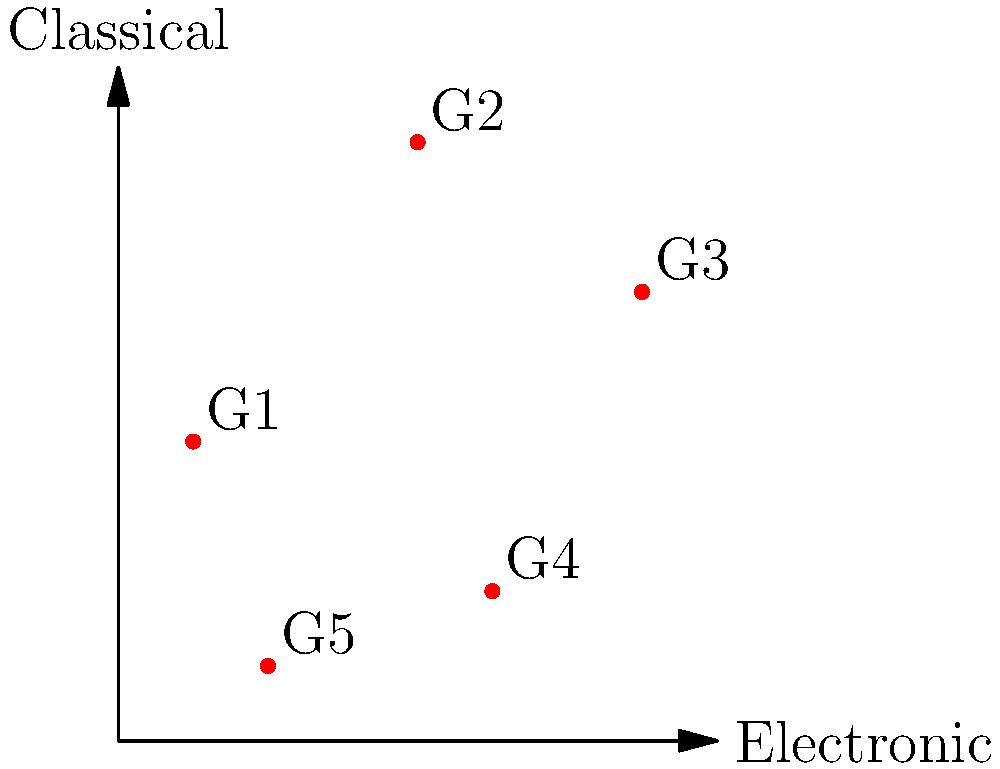In a study on the evolution of electronic music, five genres (G1 to G5) are plotted on a scatter plot based on their electronic and classical influences. The coordinates of these genres are G1(0,0), G2(3,4), G3(6,2), G4(4,-2), and G5(1,-3). Calculate the area of the polygon formed by connecting these points in the order given. How does this area relate to the diversity of electronic music genres? To calculate the area of the polygon, we can use the Shoelace formula (also known as the surveyor's formula). The steps are as follows:

1) The Shoelace formula for a polygon with vertices $(x_1, y_1), (x_2, y_2), ..., (x_n, y_n)$ is:

   $$Area = \frac{1}{2}|(x_1y_2 + x_2y_3 + ... + x_ny_1) - (y_1x_2 + y_2x_3 + ... + y_nx_1)|$$

2) Substituting our points:
   $$(x_1, y_1) = (0, 0)$$
   $$(x_2, y_2) = (3, 4)$$
   $$(x_3, y_3) = (6, 2)$$
   $$(x_4, y_4) = (4, -2)$$
   $$(x_5, y_5) = (1, -3)$$

3) Applying the formula:

   $$Area = \frac{1}{2}|(0\cdot4 + 3\cdot2 + 6\cdot(-2) + 4\cdot(-3) + 1\cdot0) - (0\cdot3 + 4\cdot6 + 2\cdot4 + (-2)\cdot1 + (-3)\cdot0)|$$

4) Simplifying:

   $$Area = \frac{1}{2}|(0 + 6 - 12 - 12 + 0) - (0 + 24 + 8 - 2 + 0)|$$
   $$Area = \frac{1}{2}|(-18) - (30)|$$
   $$Area = \frac{1}{2}|-18 - 30|$$
   $$Area = \frac{1}{2}|-48|$$
   $$Area = \frac{1}{2}(48) = 24$$

5) The area of the polygon is 24 square units.

This area represents the spread of these genres in the electronic-classical music space. A larger area would indicate a greater diversity in the mix of electronic and classical influences across these genres, showcasing the evolution and variety in electronic music. The shape and size of this polygon reflect how these genres have developed unique combinations of electronic and classical elements, demonstrating the rich tapestry of electronic music's evolution.
Answer: 24 square units; larger area indicates greater genre diversity 